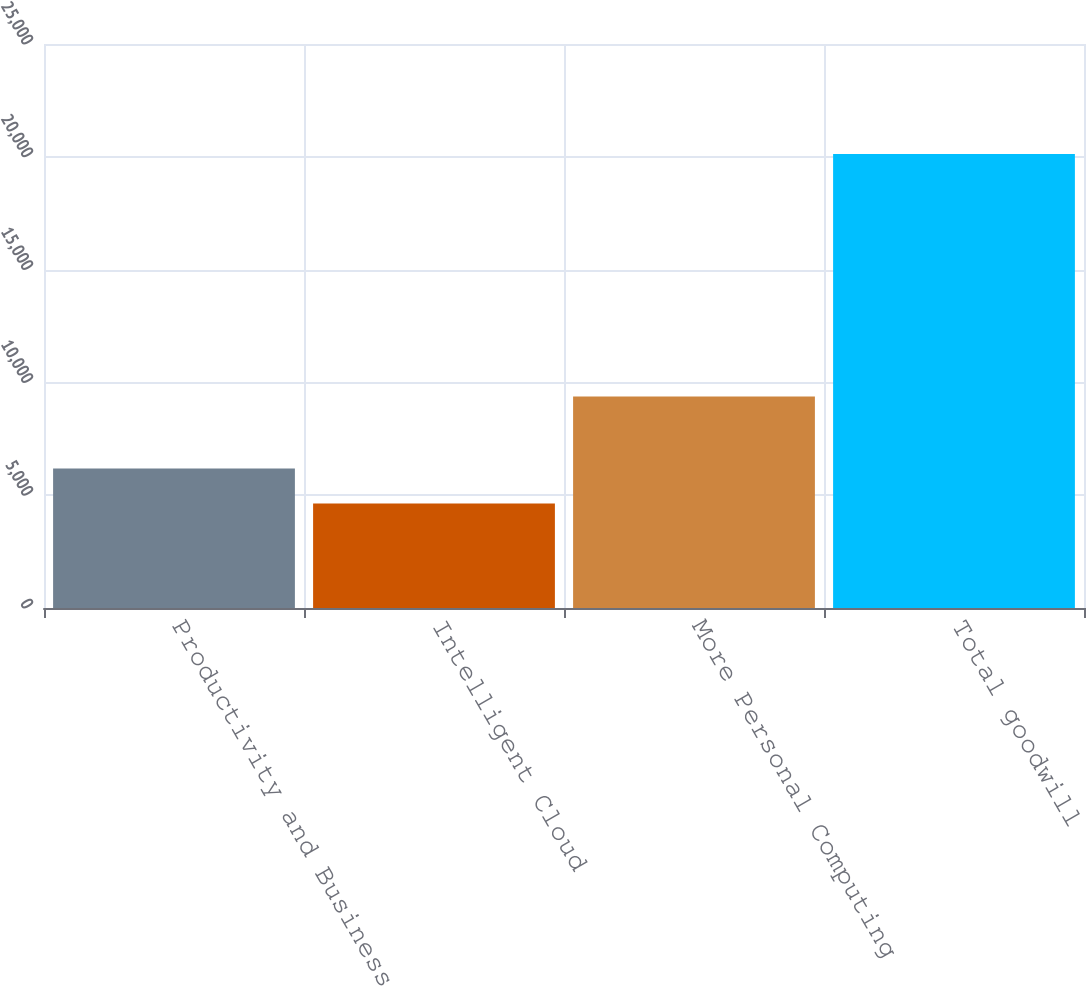<chart> <loc_0><loc_0><loc_500><loc_500><bar_chart><fcel>Productivity and Business<fcel>Intelligent Cloud<fcel>More Personal Computing<fcel>Total goodwill<nl><fcel>6180.6<fcel>4631<fcel>9380<fcel>20127<nl></chart> 